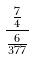<formula> <loc_0><loc_0><loc_500><loc_500>\frac { \frac { 7 } { 4 } } { \frac { 6 } { 3 7 7 } }</formula> 